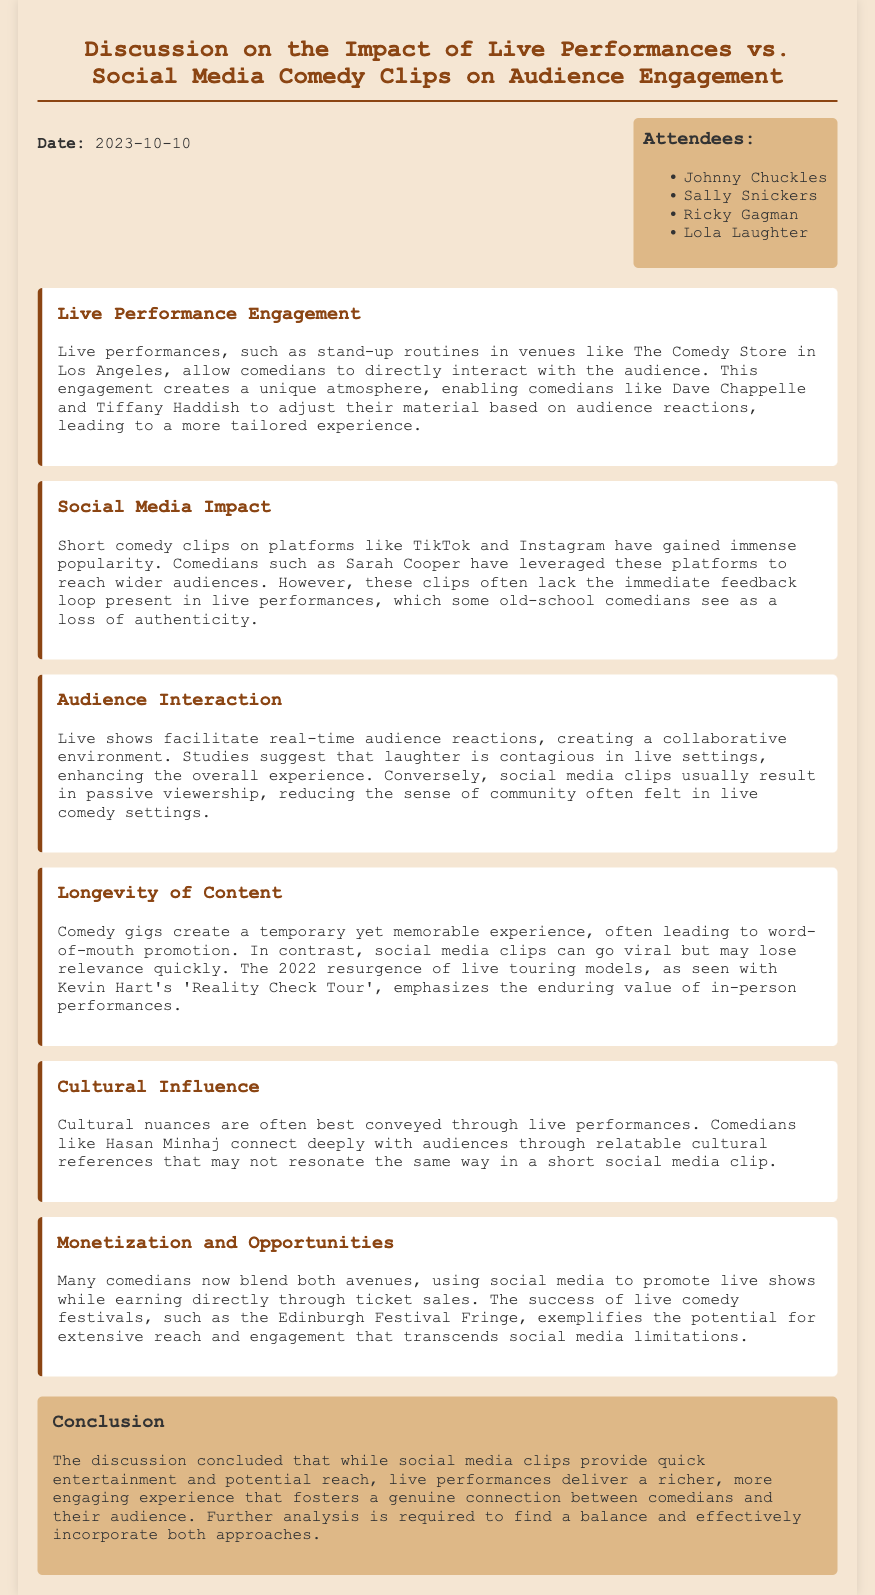What is the date of the meeting? The date of the meeting is mentioned in the document as October 10, 2023.
Answer: October 10, 2023 Who are the attendees of the meeting? The document lists the attendees by name in the attendees section.
Answer: Johnny Chuckles, Sally Snickers, Ricky Gagman, Lola Laughter Which comedian's tour is mentioned as an example of live touring? The example of a live tour is found in the section discussing the longevity of content, referring specifically to a tour conducted by Kevin Hart.
Answer: Reality Check Tour What type of comedy engagement creates a unique atmosphere? The document specifies that live performances create a unique atmosphere for audience engagement.
Answer: Live performances What is the primary downside of social media comedy clips according to the discussion? The downside of social media clips is highlighted in terms of lacking the immediate feedback loop present in live performances.
Answer: Loss of authenticity According to the document, which comedian uses social media clips to reach wider audiences? The document mentions Sarah Cooper as an example of a comedian leveraging social media for wider reach.
Answer: Sarah Cooper What effect does laughter have in live settings? The document notes that laughter is contagious in live settings, enhancing the overall experience.
Answer: Contagious What was the conclusion regarding the balance of comedy approaches? The conclusion indicates that further analysis is needed to find a balance between live performances and social media clips.
Answer: Further analysis required 